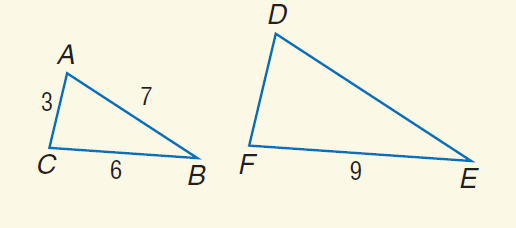Question: Find the perimeter of \triangle D E F if \triangle D E F \sim \triangle A B C.
Choices:
A. 15
B. 16
C. 24
D. 30
Answer with the letter. Answer: C 